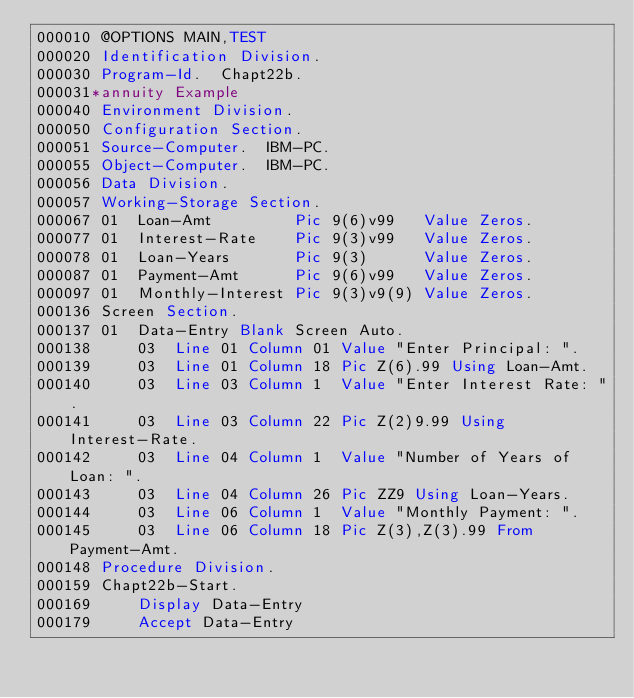<code> <loc_0><loc_0><loc_500><loc_500><_COBOL_>000010 @OPTIONS MAIN,TEST
000020 Identification Division.
000030 Program-Id.  Chapt22b.
000031*annuity Example
000040 Environment Division.
000050 Configuration Section.
000051 Source-Computer.  IBM-PC.
000055 Object-Computer.  IBM-PC.
000056 Data Division.
000057 Working-Storage Section.
000067 01  Loan-Amt         Pic 9(6)v99   Value Zeros.
000077 01  Interest-Rate    Pic 9(3)v99   Value Zeros.
000078 01  Loan-Years       Pic 9(3)      Value Zeros.
000087 01  Payment-Amt      Pic 9(6)v99   Value Zeros.
000097 01  Monthly-Interest Pic 9(3)v9(9) Value Zeros.
000136 Screen Section.
000137 01  Data-Entry Blank Screen Auto.
000138     03  Line 01 Column 01 Value "Enter Principal: ".
000139     03  Line 01 Column 18 Pic Z(6).99 Using Loan-Amt.
000140     03  Line 03 Column 1  Value "Enter Interest Rate: ".
000141     03  Line 03 Column 22 Pic Z(2)9.99 Using Interest-Rate.
000142     03  Line 04 Column 1  Value "Number of Years of Loan: ".
000143     03  Line 04 Column 26 Pic ZZ9 Using Loan-Years.
000144     03  Line 06 Column 1  Value "Monthly Payment: ".
000145     03  Line 06 Column 18 Pic Z(3),Z(3).99 From Payment-Amt.
000148 Procedure Division.
000159 Chapt22b-Start.
000169     Display Data-Entry
000179     Accept Data-Entry</code> 